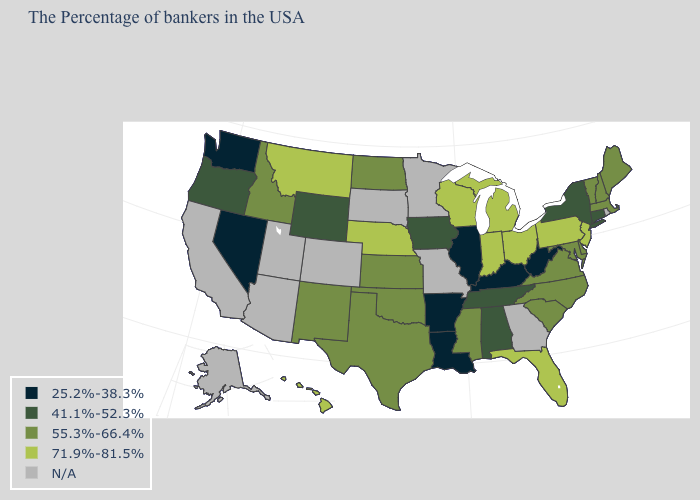What is the value of Tennessee?
Short answer required. 41.1%-52.3%. Name the states that have a value in the range N/A?
Keep it brief. Rhode Island, Georgia, Missouri, Minnesota, South Dakota, Colorado, Utah, Arizona, California, Alaska. Which states hav the highest value in the West?
Short answer required. Montana, Hawaii. Name the states that have a value in the range 25.2%-38.3%?
Give a very brief answer. West Virginia, Kentucky, Illinois, Louisiana, Arkansas, Nevada, Washington. What is the value of Missouri?
Short answer required. N/A. Among the states that border New York , does New Jersey have the highest value?
Be succinct. Yes. What is the value of Nevada?
Answer briefly. 25.2%-38.3%. Among the states that border Virginia , does Kentucky have the highest value?
Answer briefly. No. Among the states that border Ohio , which have the highest value?
Short answer required. Pennsylvania, Michigan, Indiana. Does Arkansas have the lowest value in the South?
Concise answer only. Yes. What is the value of Alabama?
Concise answer only. 41.1%-52.3%. Is the legend a continuous bar?
Concise answer only. No. Name the states that have a value in the range N/A?
Quick response, please. Rhode Island, Georgia, Missouri, Minnesota, South Dakota, Colorado, Utah, Arizona, California, Alaska. What is the lowest value in the USA?
Keep it brief. 25.2%-38.3%. What is the highest value in the MidWest ?
Give a very brief answer. 71.9%-81.5%. 